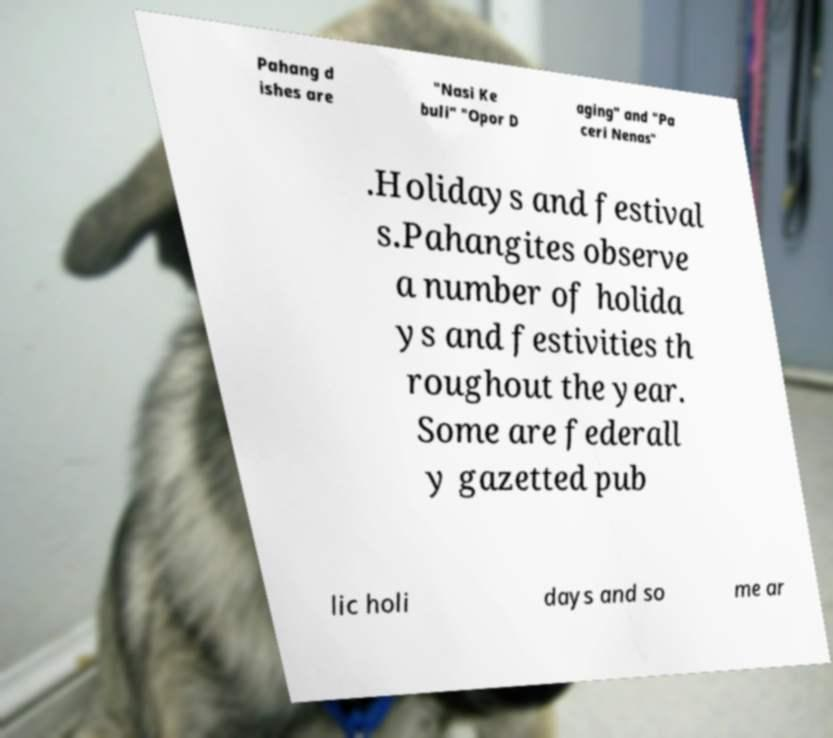Please identify and transcribe the text found in this image. Pahang d ishes are "Nasi Ke buli" "Opor D aging" and "Pa ceri Nenas" .Holidays and festival s.Pahangites observe a number of holida ys and festivities th roughout the year. Some are federall y gazetted pub lic holi days and so me ar 